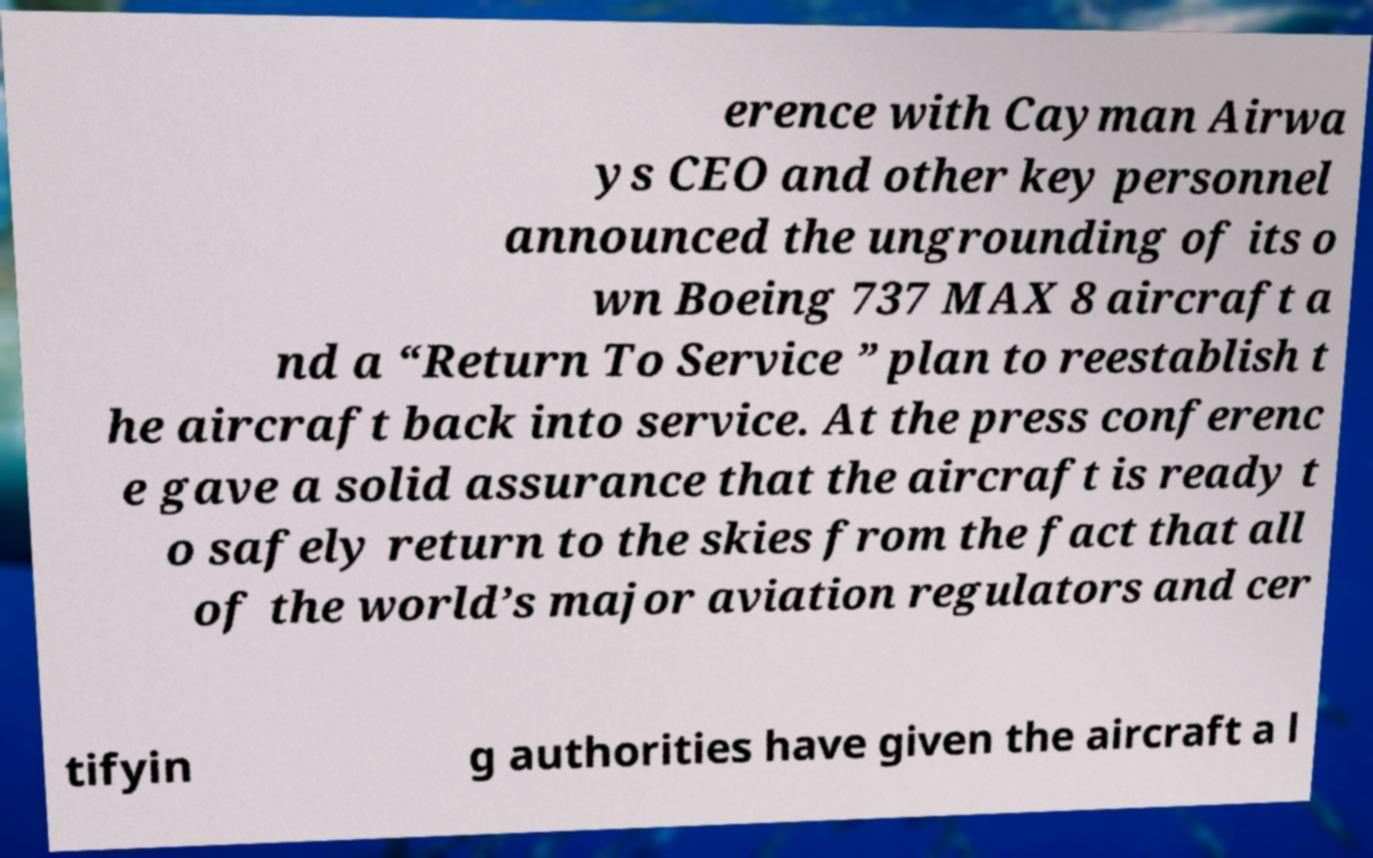Please identify and transcribe the text found in this image. erence with Cayman Airwa ys CEO and other key personnel announced the ungrounding of its o wn Boeing 737 MAX 8 aircraft a nd a “Return To Service ” plan to reestablish t he aircraft back into service. At the press conferenc e gave a solid assurance that the aircraft is ready t o safely return to the skies from the fact that all of the world’s major aviation regulators and cer tifyin g authorities have given the aircraft a l 